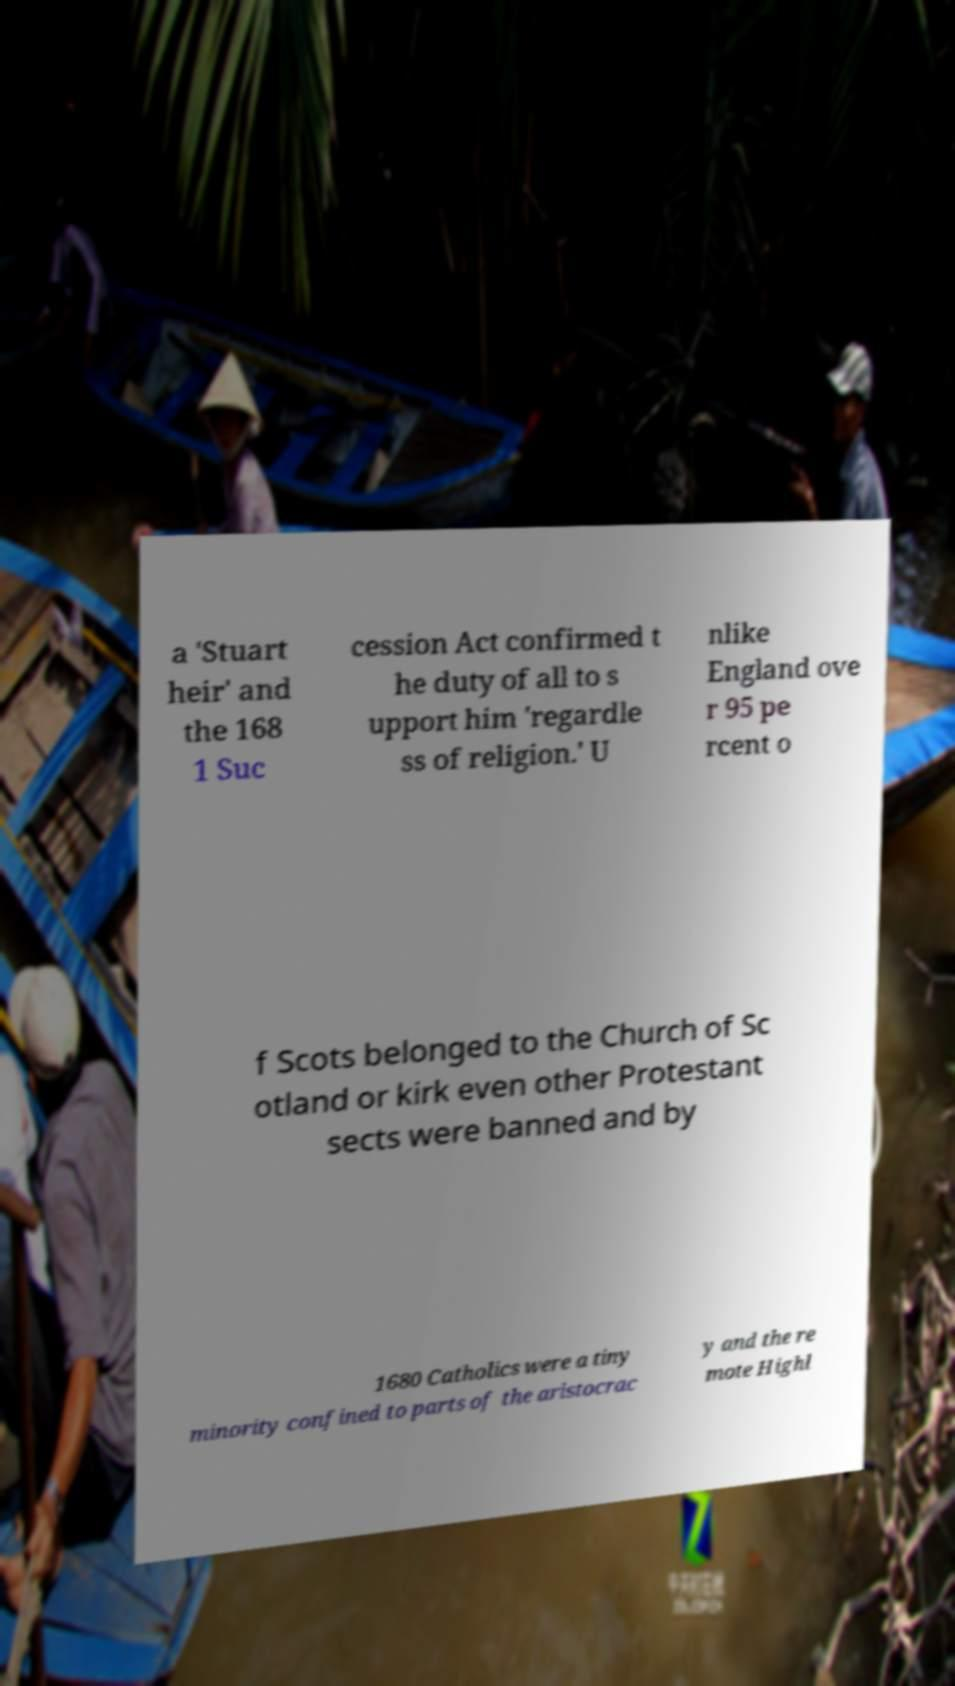Please read and relay the text visible in this image. What does it say? a 'Stuart heir' and the 168 1 Suc cession Act confirmed t he duty of all to s upport him 'regardle ss of religion.' U nlike England ove r 95 pe rcent o f Scots belonged to the Church of Sc otland or kirk even other Protestant sects were banned and by 1680 Catholics were a tiny minority confined to parts of the aristocrac y and the re mote Highl 